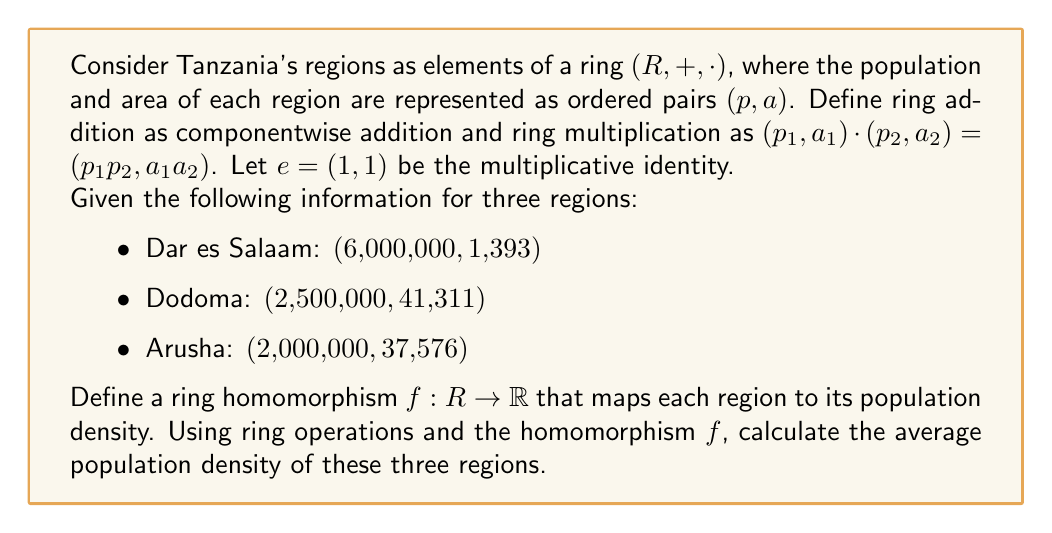Can you answer this question? To solve this problem, we'll follow these steps:

1) First, we need to define the ring homomorphism $f: R \rightarrow \mathbb{R}$ that maps each region to its population density. For a region $(p, a)$, the population density is $\frac{p}{a}$. So, we can define $f$ as:

   $f((p, a)) = \frac{p}{a}$

2) Now, let's calculate the population density for each region:

   Dar es Salaam: $f((6,000,000, 1,393)) = \frac{6,000,000}{1,393} \approx 4,307.25$ people/km²
   Dodoma: $f((2,500,000, 41,311)) = \frac{2,500,000}{41,311} \approx 60.52$ people/km²
   Arusha: $f((2,000,000, 37,576)) = \frac{2,000,000}{37,576} \approx 53.23$ people/km²

3) To calculate the average, we need to add these densities and divide by 3. In our ring, addition is componentwise, so we first add the regions:

   $(6,000,000, 1,393) + (2,500,000, 41,311) + (2,000,000, 37,576) = (10,500,000, 80,280)$

4) Now, we need to divide this sum by 3. In our ring, we can represent 3 as $(3, 3)$, and division is equivalent to multiplication by the inverse. The inverse of $(3, 3)$ is $(\frac{1}{3}, \frac{1}{3})$. So:

   $(10,500,000, 80,280) \cdot (\frac{1}{3}, \frac{1}{3}) = (3,500,000, 26,760)$

5) Finally, we apply our homomorphism $f$ to this result:

   $f((3,500,000, 26,760)) = \frac{3,500,000}{26,760} \approx 130.79$ people/km²

This is the average population density of the three regions.
Answer: The average population density of the three regions is approximately 130.79 people/km². 